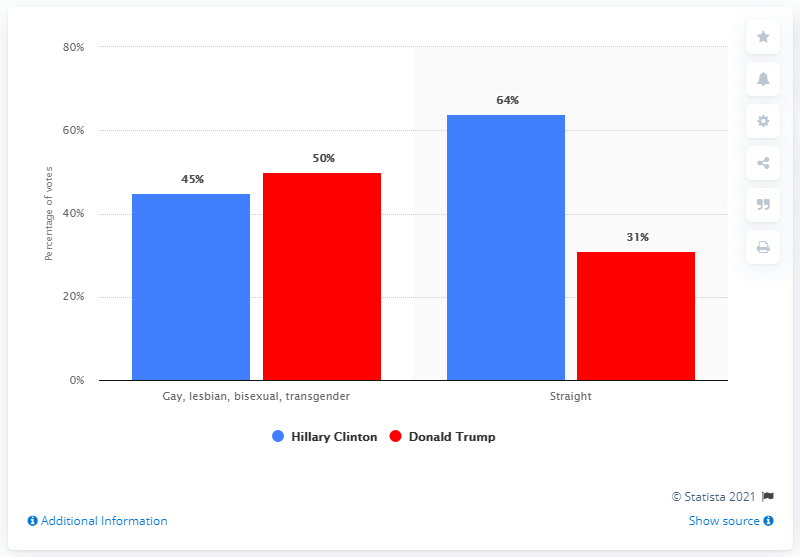Specify some key components in this picture. Hillary Clinton's sexual orientation is straight. The difference between the polls for Hilary Clinton and Donald Trump is 28%. A majority of voters who identified as gay, lesbian, bisexual, or transgender voted for Hillary Clinton, with 78% of their votes going to her. 